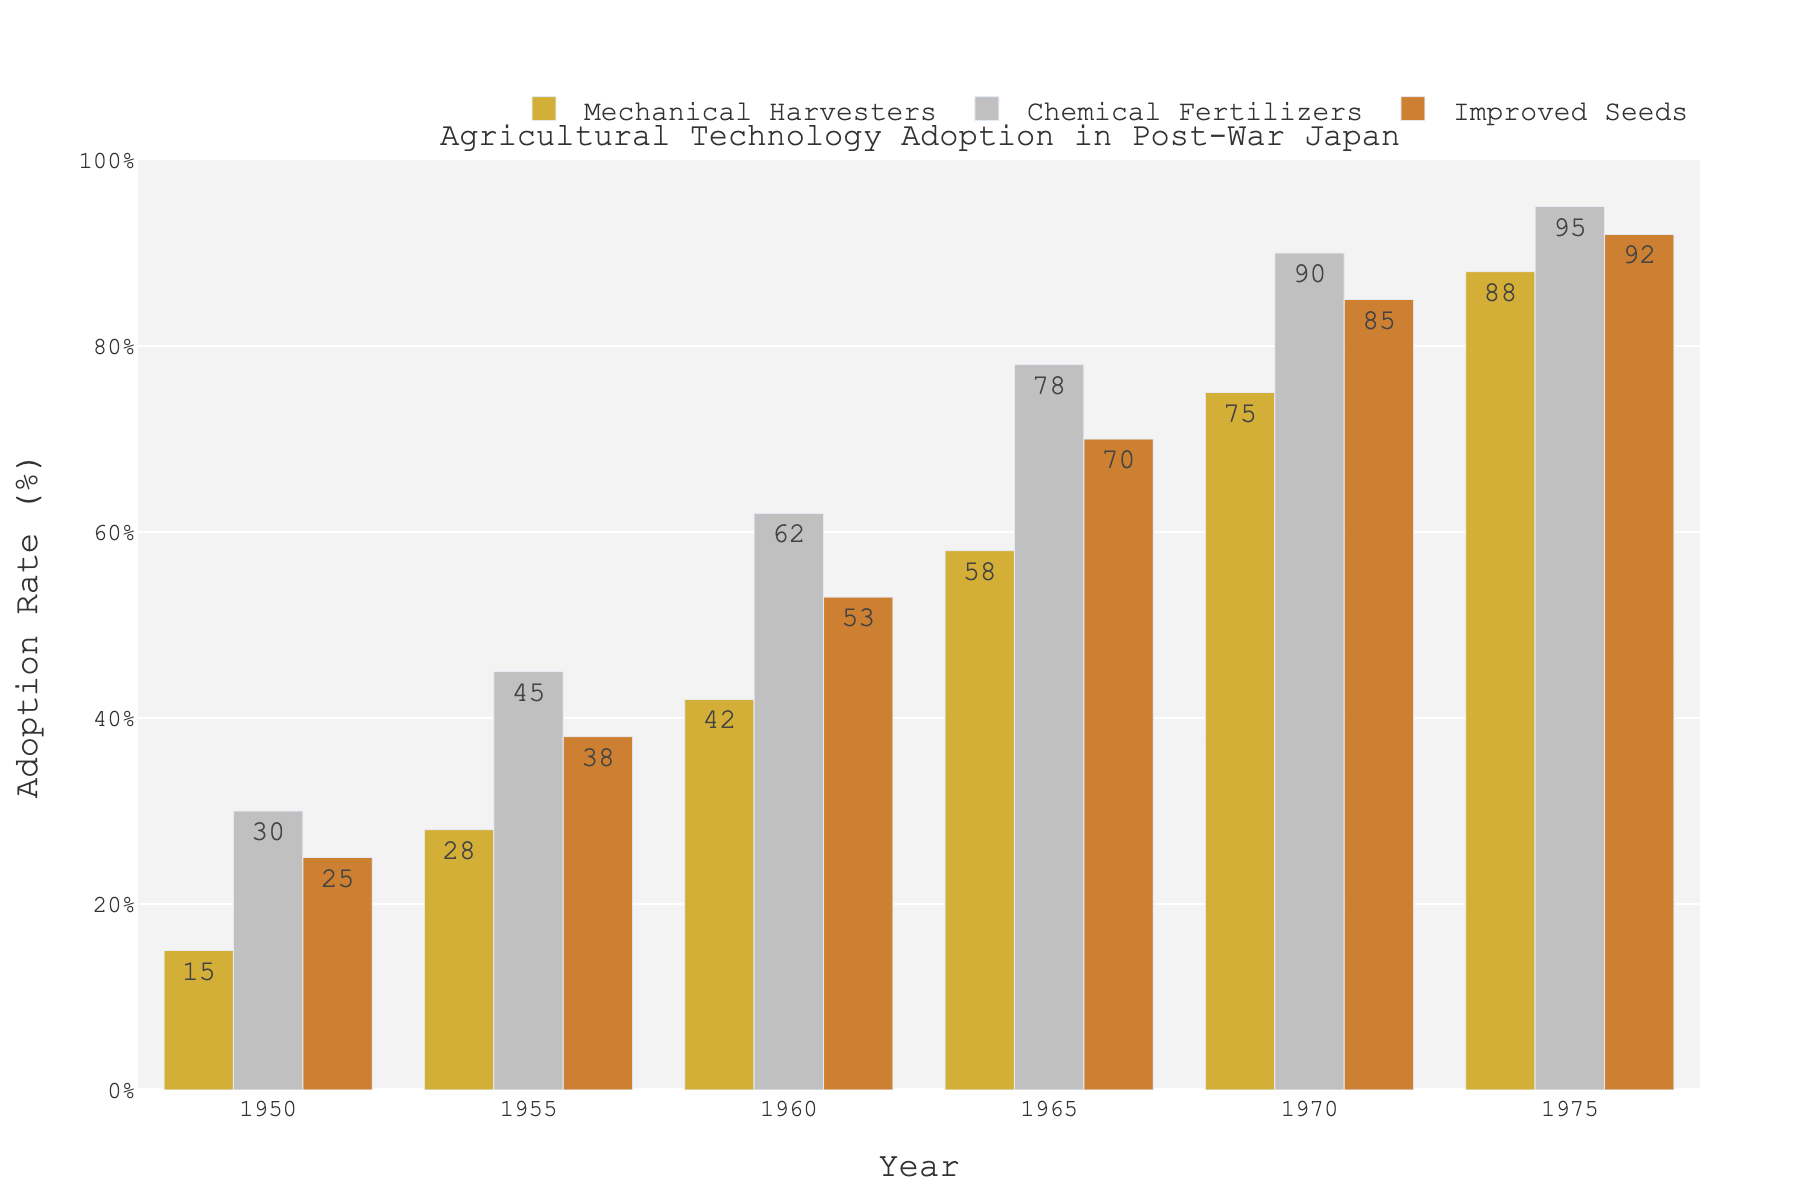What is the adoption rate of Chemical Fertilizers in the year 1960? In the bar chart, locate the bar corresponding to Chemical Fertilizers for the year 1960. The height of the bar represents the adoption rate, which is 62%.
Answer: 62% Which technology had the highest adoption rate in 1975? In the bar chart, for the year 1975, compare the heights of the bars representing Mechanical Harvesters, Chemical Fertilizers, and Improved Seeds. The tallest bar is for Chemical Fertilizers, with adoption rates reaching 95%.
Answer: Chemical Fertilizers What is the difference in adoption rates of Mechanical Harvesters between 1950 and 1970? Look at the heights of the bars for Mechanical Harvesters for the years 1950 and 1970. The adoption rate in 1950 is 15%, and in 1970 it is 75%. Subtract 15% from 75% to get the difference.
Answer: 60% Between the years 1960 and 1965, which technology experienced the greatest increase in adoption rate? Compare the changes in the heights of bars for Mechanical Harvesters, Chemical Fertilizers, and Improved Seeds between 1960 and 1965. Mechanical Harvesters increased from 42% to 58%, Chemical Fertilizers from 62% to 78%, and Improved Seeds from 53% to 70%. The greatest increase is for Improved Seeds at 17%.
Answer: Improved Seeds What is the average adoption rate of Improved Seeds over all the years presented? Find the adoption rates of Improved Seeds for each year: 1950 (25%), 1955 (38%), 1960 (53%), 1965 (70%), 1970 (85%), 1975 (92%). Add them together to get 363%, then divide by 6 (total number of years).
Answer: 60.5% By how much did the adoption rate of Chemical Fertilizers increase from 1955 to 1975? Look at the heights of the bars for Chemical Fertilizers in 1955 (45%) and in 1975 (95%). Subtract 45% from 95% to find the increase.
Answer: 50% Which technology had the lowest initial adoption rate in 1950? For the year 1950, compare the heights of the bars for each technology. The bar for Mechanical Harvesters has the lowest adoption rate, which is 15%.
Answer: Mechanical Harvesters Which technology showed a consistent increase in adoption rate every year? Examine the heights of the bars for each technology across all the years. Mechanical Harvesters, Chemical Fertilizers, and Improved Seeds all show a consistent increase in their adoption rates every year. Therefore, all three showed a consistent increase.
Answer: Mechanical Harvesters, Chemical Fertilizers, Improved Seeds How does the adoption rate of Improved Seeds in 1965 compare to the adoption rate of Mechanical Harvesters in 1975? Compare the height of the bar for Improved Seeds in 1965 (70%) with the height of the bar for Mechanical Harvesters in 1975 (88%). The adoption rate of Improved Seeds in 1965 is less than that of Mechanical Harvesters in 1975.
Answer: Less 